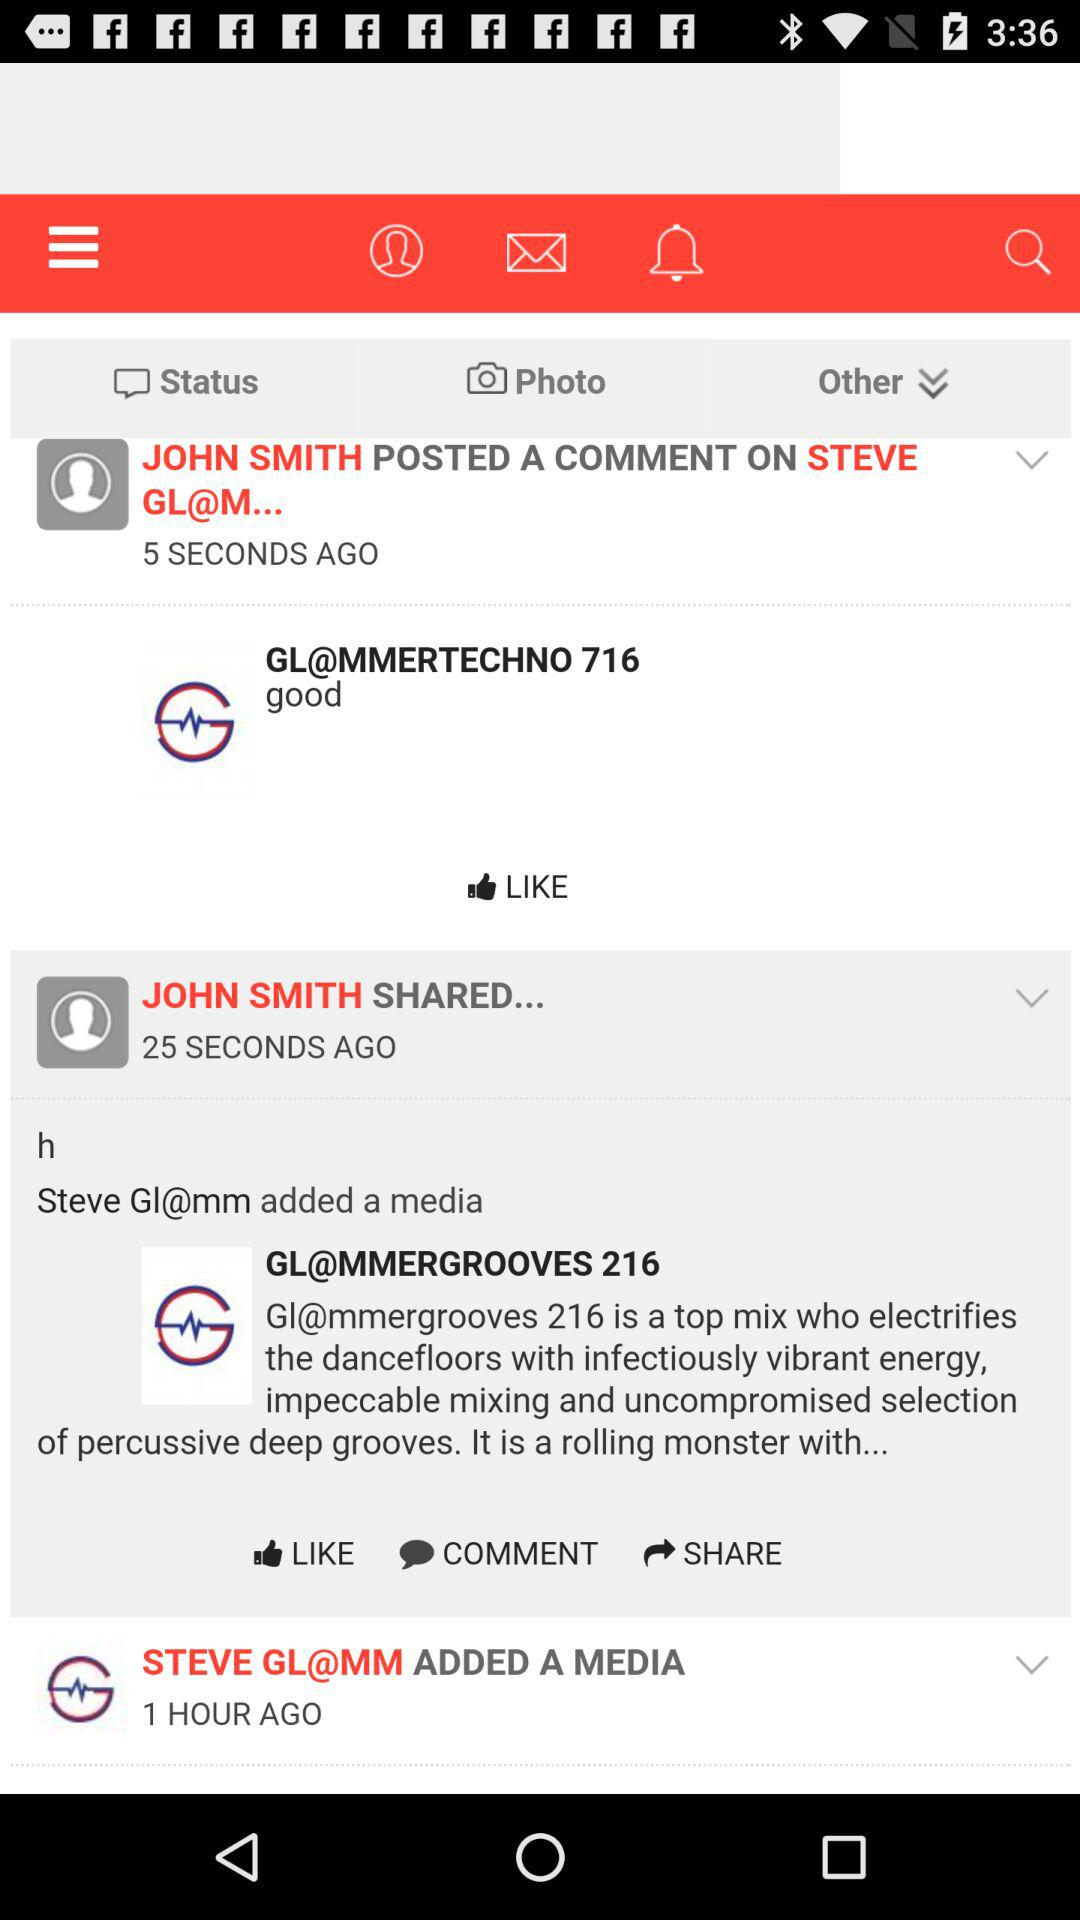How many more seconds ago was the post shared than the comment?
Answer the question using a single word or phrase. 20 